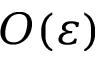<formula> <loc_0><loc_0><loc_500><loc_500>O ( \varepsilon )</formula> 